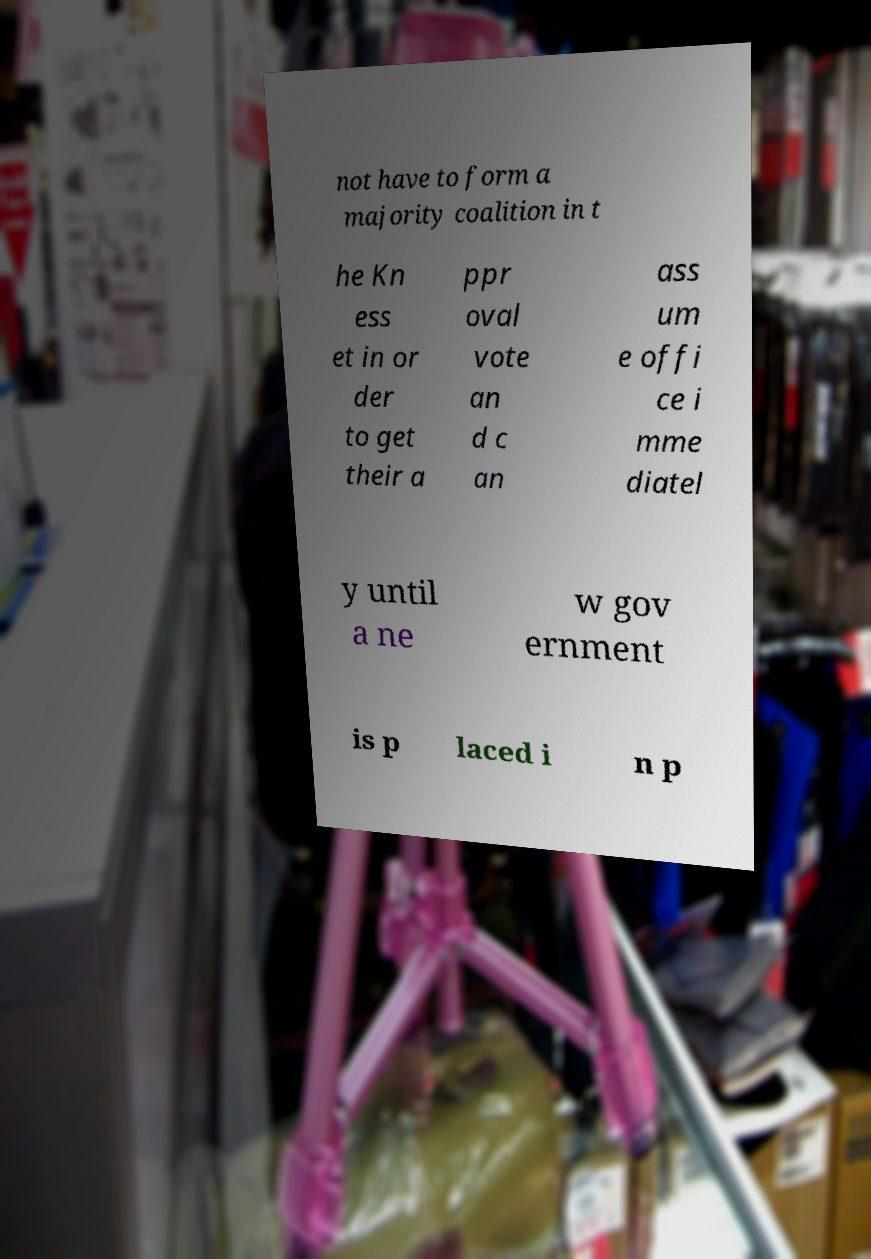I need the written content from this picture converted into text. Can you do that? not have to form a majority coalition in t he Kn ess et in or der to get their a ppr oval vote an d c an ass um e offi ce i mme diatel y until a ne w gov ernment is p laced i n p 